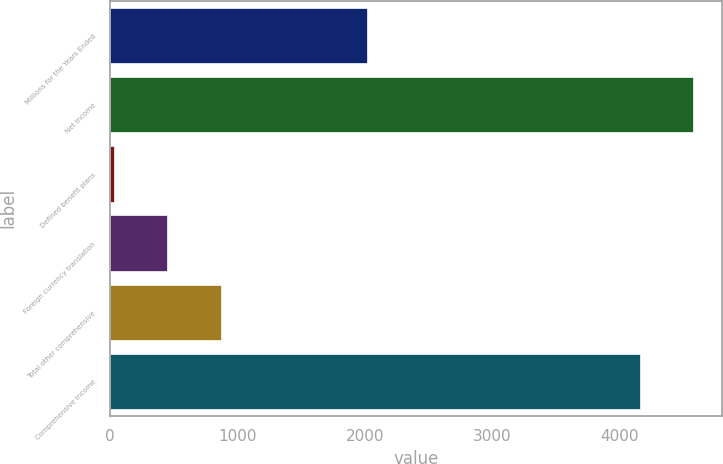<chart> <loc_0><loc_0><loc_500><loc_500><bar_chart><fcel>Millions for the Years Ended<fcel>Net income<fcel>Defined benefit plans<fcel>Foreign currency translation<fcel>Total other comprehensive<fcel>Comprehensive income<nl><fcel>2016<fcel>4576.4<fcel>29<fcel>449.4<fcel>869.8<fcel>4156<nl></chart> 